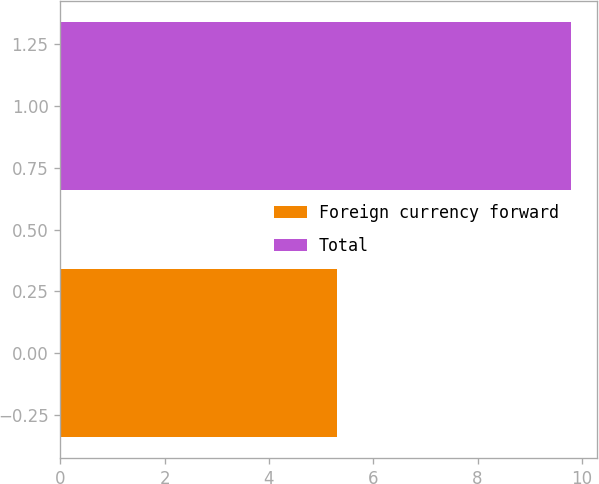Convert chart to OTSL. <chart><loc_0><loc_0><loc_500><loc_500><bar_chart><fcel>Foreign currency forward<fcel>Total<nl><fcel>5.3<fcel>9.8<nl></chart> 